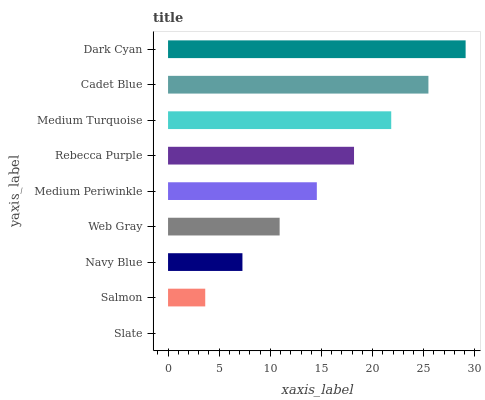Is Slate the minimum?
Answer yes or no. Yes. Is Dark Cyan the maximum?
Answer yes or no. Yes. Is Salmon the minimum?
Answer yes or no. No. Is Salmon the maximum?
Answer yes or no. No. Is Salmon greater than Slate?
Answer yes or no. Yes. Is Slate less than Salmon?
Answer yes or no. Yes. Is Slate greater than Salmon?
Answer yes or no. No. Is Salmon less than Slate?
Answer yes or no. No. Is Medium Periwinkle the high median?
Answer yes or no. Yes. Is Medium Periwinkle the low median?
Answer yes or no. Yes. Is Slate the high median?
Answer yes or no. No. Is Slate the low median?
Answer yes or no. No. 